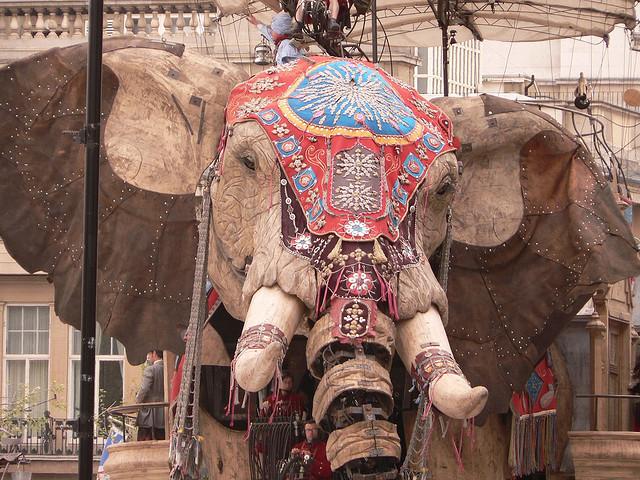Is this an African or Asian elephant?
Write a very short answer. Asian. What is on the elephants head?
Short answer required. Decoration. Is this a real elephant?
Concise answer only. Yes. 